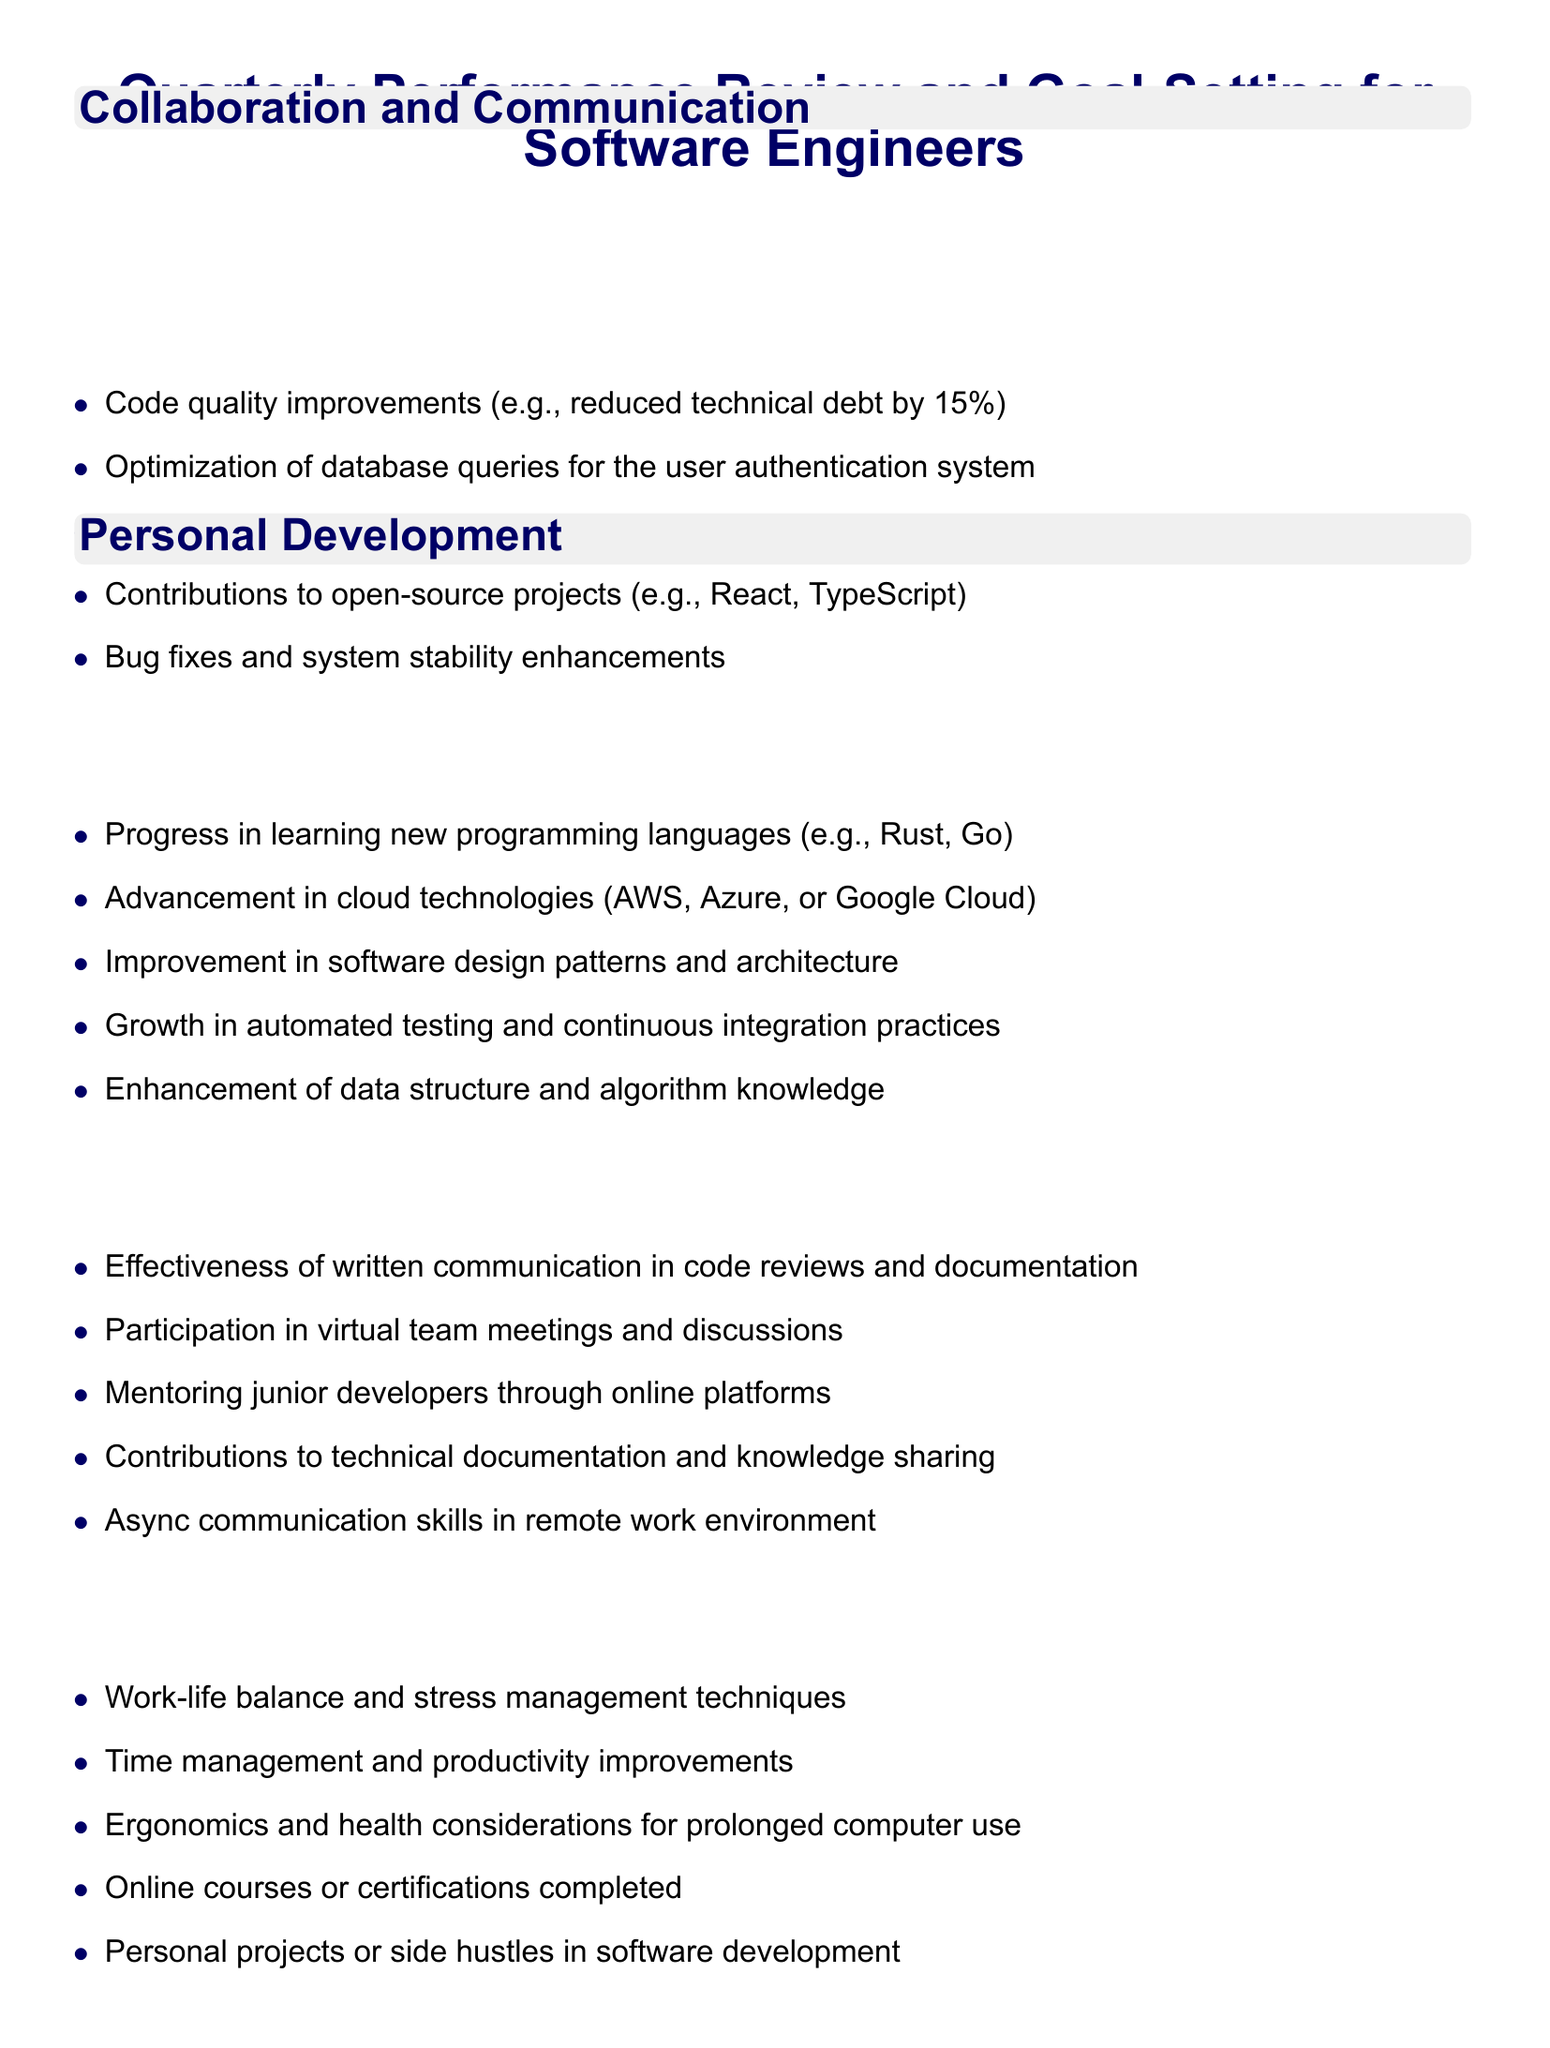What is the main agenda title? The main agenda title is stated at the beginning of the document, highlighting the focus on performance review and goal-setting for software engineers.
Answer: Quarterly Performance Review and Goal-Setting for Software Engineers What is one of the listed contributions to open-source projects? Contributions to open-source projects are part of the "Review of Technical Accomplishments" section listed in the document.
Answer: React What are the two programming languages mentioned for skill development? The document mentions specific programming languages as part of the skill development, highlighting the areas of progress.
Answer: Rust, Go What is a personal development goal listed in the document? The goal in the personal development section outlines improvement areas relevant to individual growth.
Answer: Time management and productivity improvements What type of communication is assessed in the "Collaboration and Communication" section? The document specifies aspects of communication that are reviewed under the section on collaboration, focusing on various methods of interaction.
Answer: Written communication How many items are listed under "Goal Setting for Next Quarter"? The number of items gives an indication of the range of goals being set for the upcoming quarter.
Answer: Five What is a key performance metric listed in the document? Metrics focus on measurable outcomes essential for assessing performance and effectiveness as outlined in the document.
Answer: Bug resolution time and effectiveness What is the last section of the document focused on? The last section deals with future aspirations and directions in one's career path, a key component of the agenda.
Answer: Career Path Discussion 